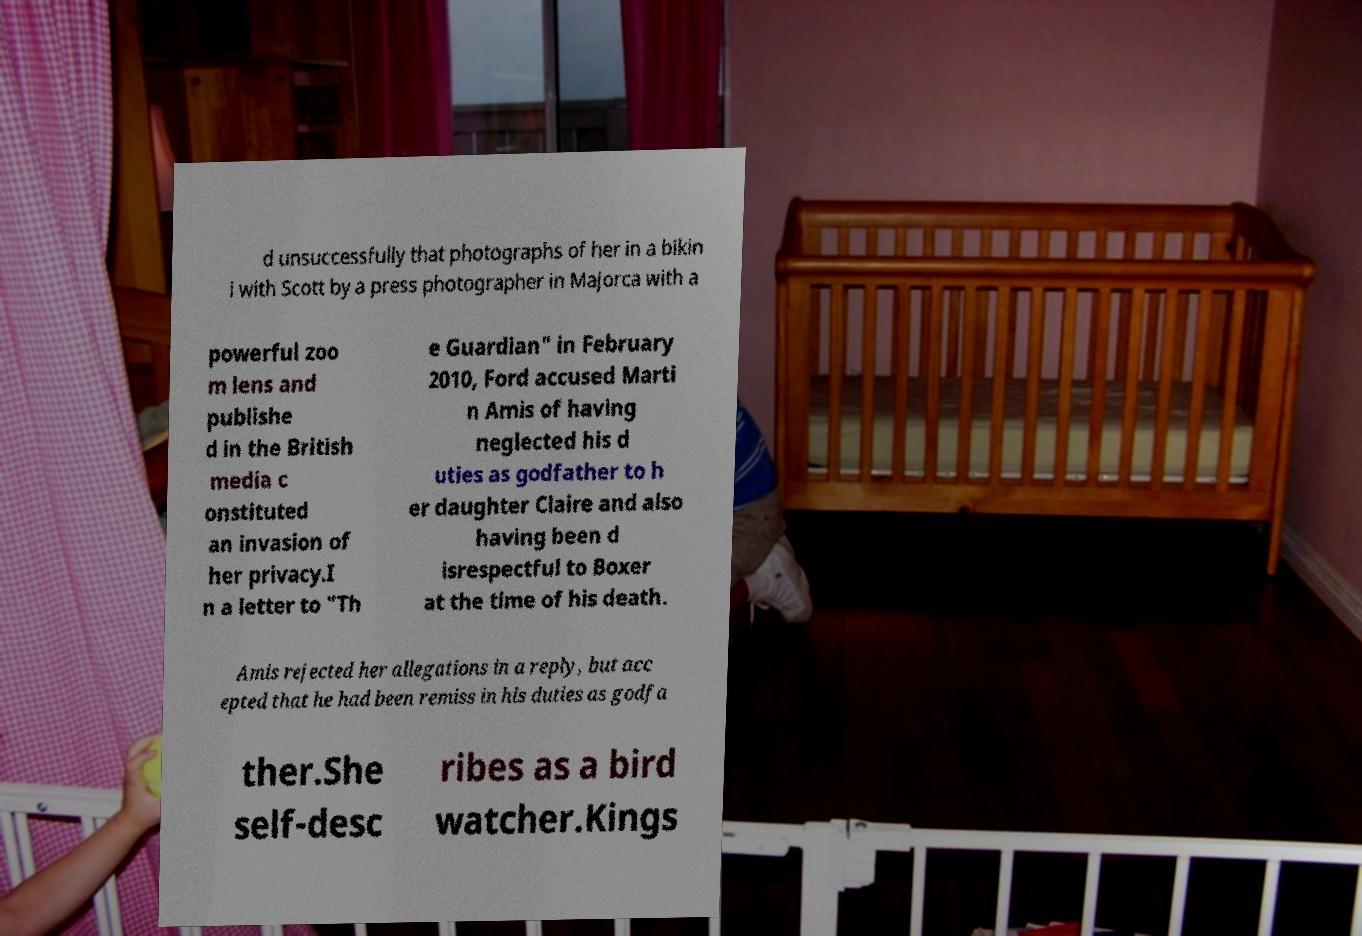Could you assist in decoding the text presented in this image and type it out clearly? d unsuccessfully that photographs of her in a bikin i with Scott by a press photographer in Majorca with a powerful zoo m lens and publishe d in the British media c onstituted an invasion of her privacy.I n a letter to "Th e Guardian" in February 2010, Ford accused Marti n Amis of having neglected his d uties as godfather to h er daughter Claire and also having been d isrespectful to Boxer at the time of his death. Amis rejected her allegations in a reply, but acc epted that he had been remiss in his duties as godfa ther.She self-desc ribes as a bird watcher.Kings 